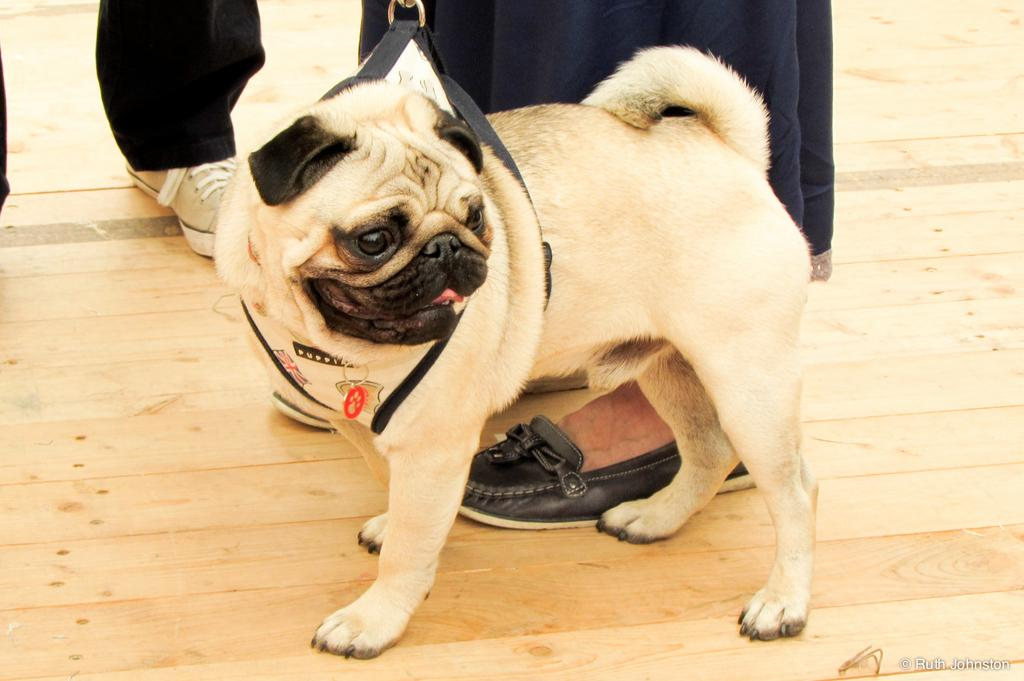What type of animal is in the image? There is a dog in the image. What colors can be seen on the dog? The dog is cream and black in color. What accessory is visible on the dog? There is a dog belt in the image. What type of flooring is in the image? There is a wooden floor in the image. What are the people in the image wearing? The people are wearing clothes and shoes. What type of root can be seen growing from the dog's tail in the image? There is no root growing from the dog's tail in the image. What advertisement is being displayed on the wall in the image? There is no advertisement visible in the image. 